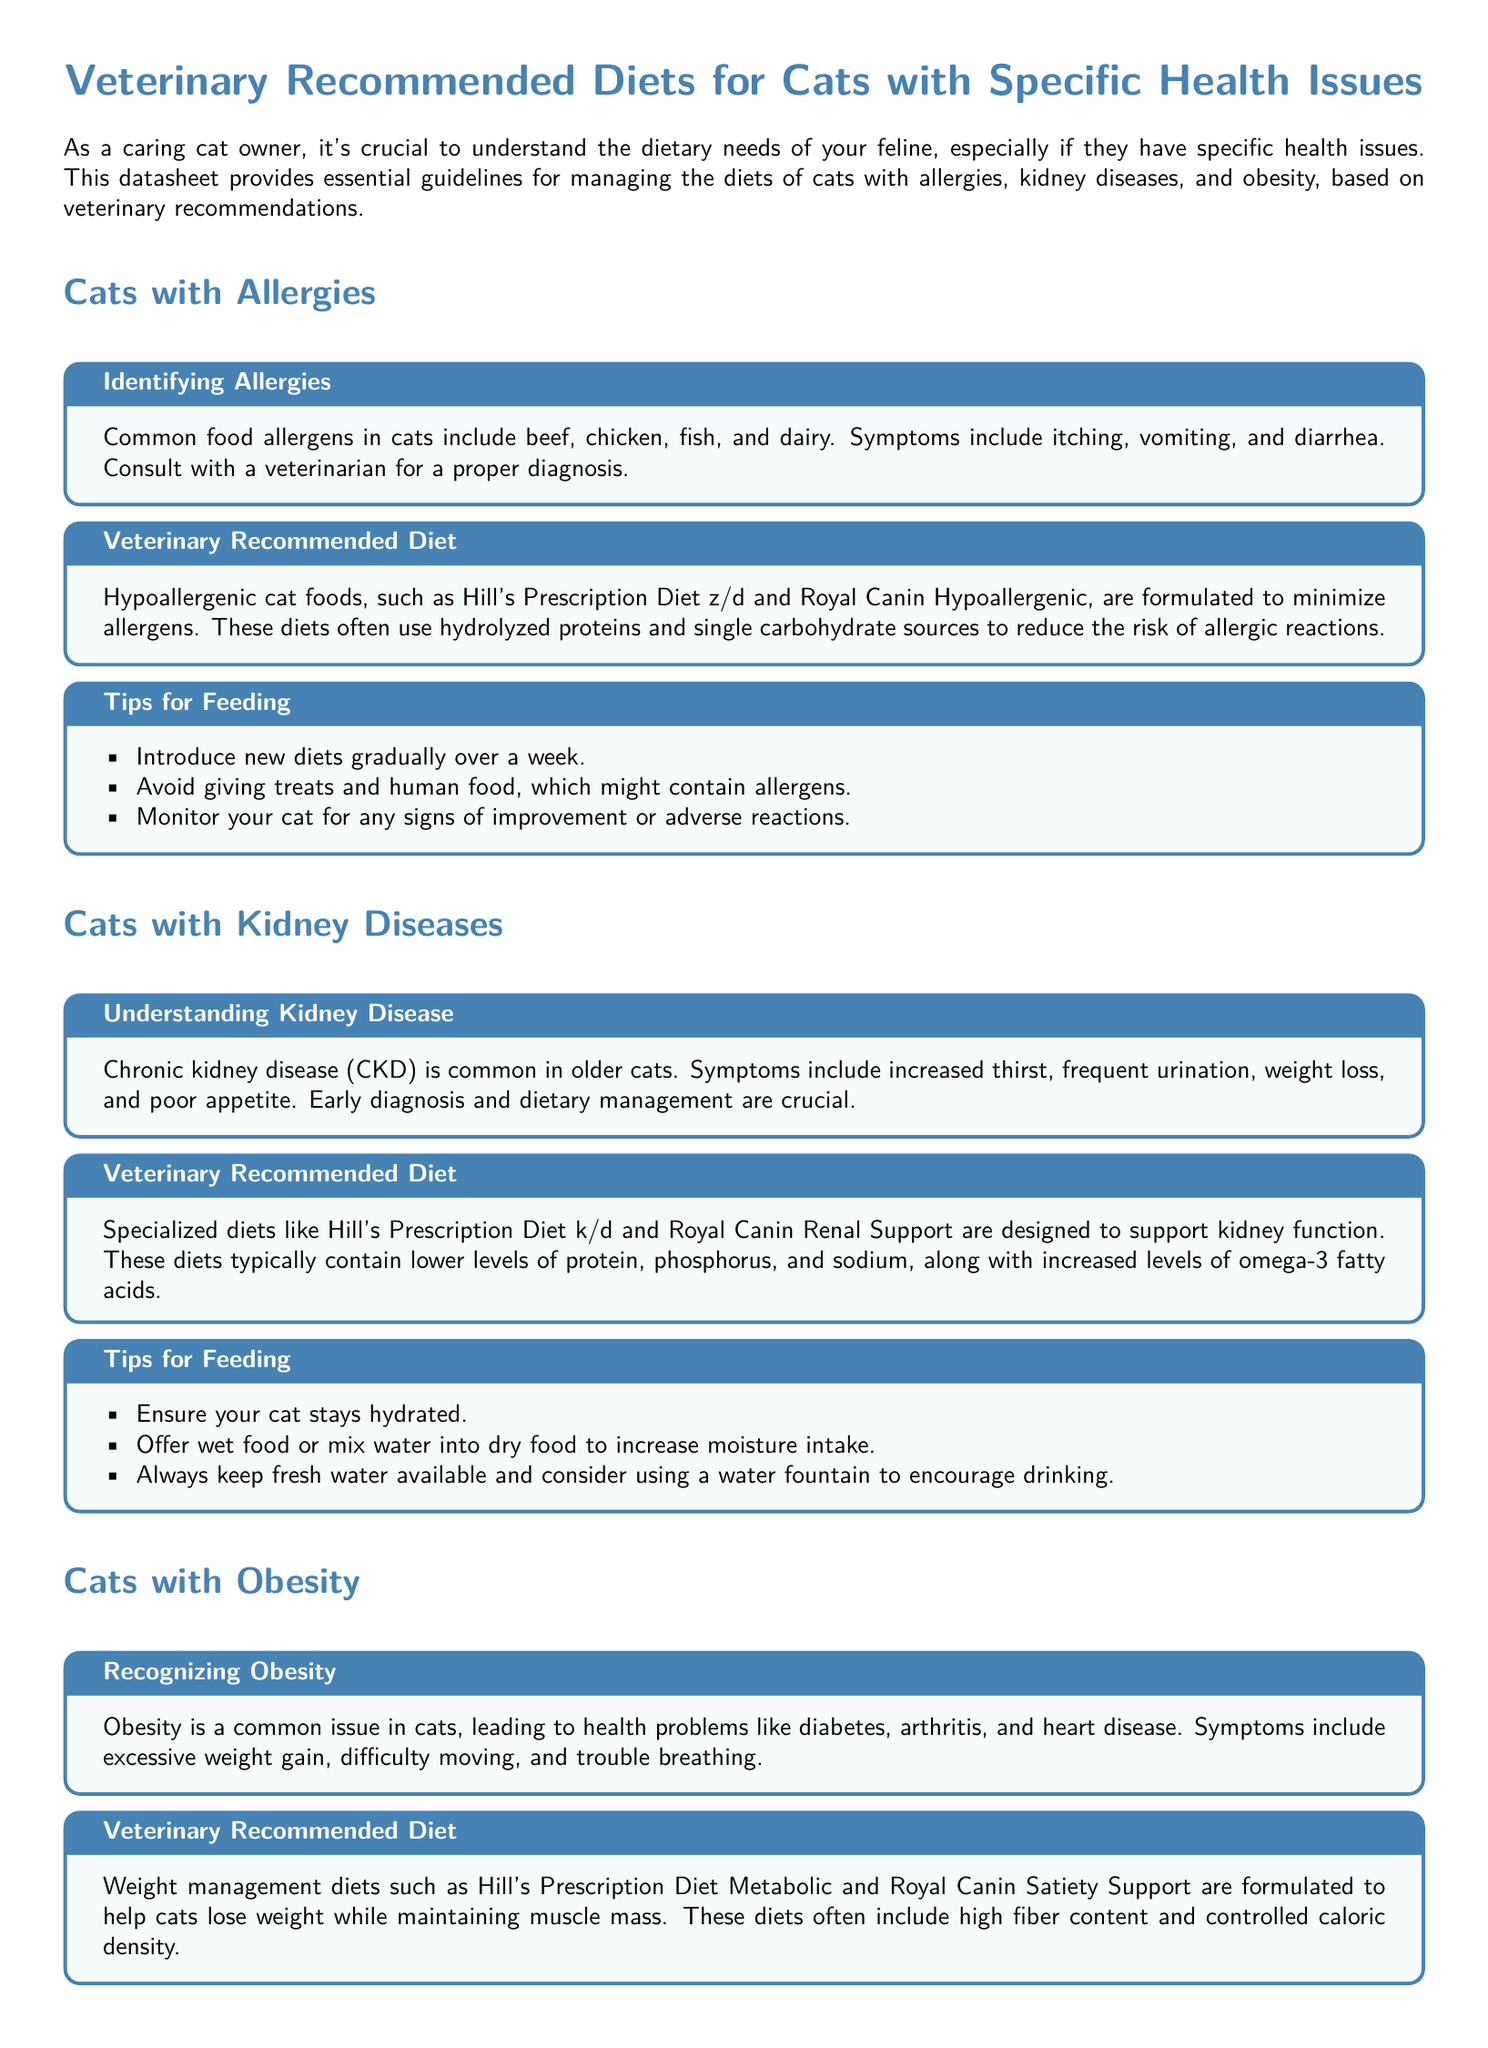What are common food allergens in cats? The document states that common allergens include beef, chicken, fish, and dairy.
Answer: beef, chicken, fish, dairy What is a recommended diet for cats with allergies? The datasheet suggests hypoallergenic cat foods such as Hill's Prescription Diet z/d and Royal Canin Hypoallergenic.
Answer: Hill's Prescription Diet z/d, Royal Canin Hypoallergenic What are symptoms of chronic kidney disease in cats? The document lists symptoms such as increased thirst, frequent urination, weight loss, and poor appetite.
Answer: increased thirst, frequent urination, weight loss, poor appetite What specialized diet is suggested for cats with kidney diseases? The document recommends specialized diets like Hill's Prescription Diet k/d and Royal Canin Renal Support.
Answer: Hill's Prescription Diet k/d, Royal Canin Renal Support How should you measure food for cats with obesity? According to the document, you should measure your cat's food and feed them at specific times rather than free-feeding.
Answer: measure food and feed at specific times What is one way to ensure hydration for cats with kidney disease? The datasheet suggests offering wet food or mixing water into dry food to increase moisture intake.
Answer: offer wet food or mix water into dry food What is the purpose of weight management diets for cats? The document explains that weight management diets help cats lose weight while maintaining muscle mass.
Answer: lose weight while maintaining muscle mass What is the concluding advice provided in the document? The conclusion emphasizes that providing the right diet is essential and to consult with a veterinarian.
Answer: consult with your veterinarian What should be avoided when feeding cats with allergies? The document advises avoiding treats and human food that might contain allergens.
Answer: treats and human food 